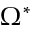<formula> <loc_0><loc_0><loc_500><loc_500>\Omega ^ { * }</formula> 